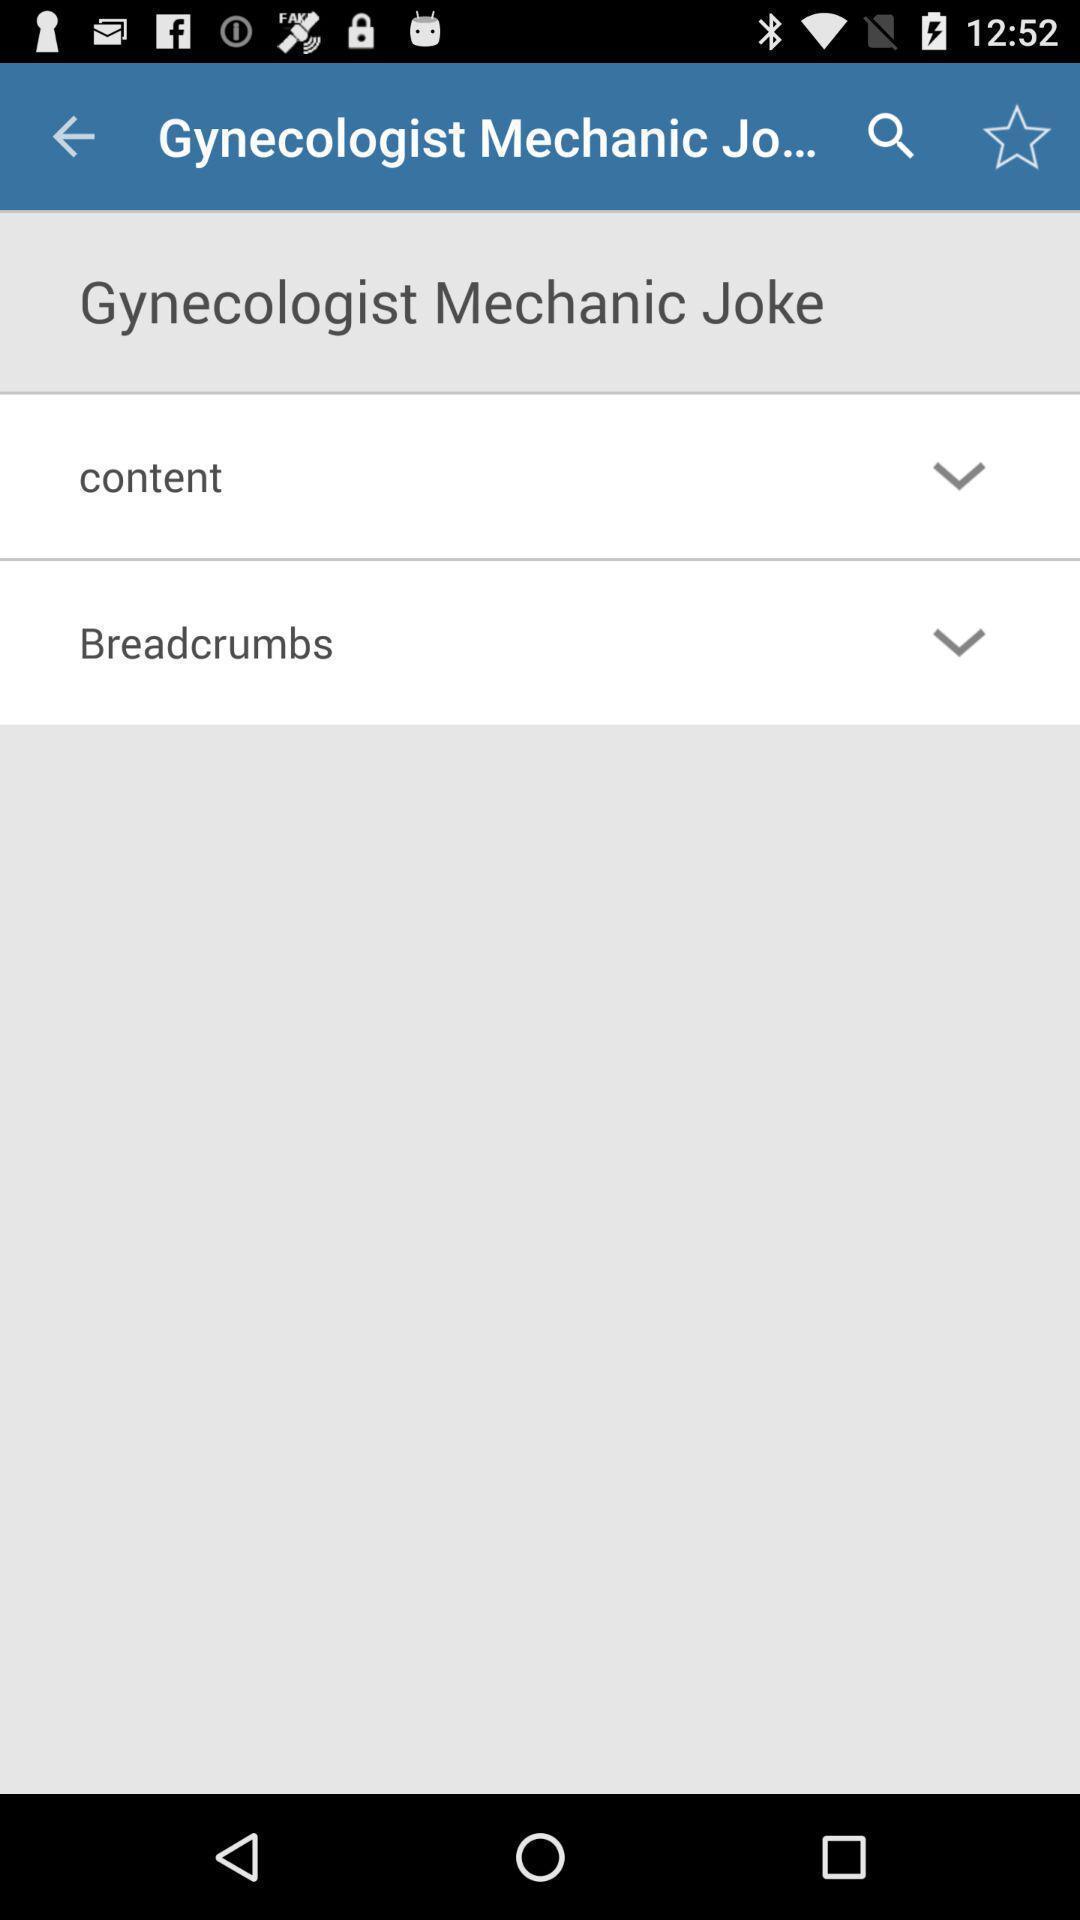Provide a detailed account of this screenshot. Window displaying a medical page. 